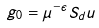<formula> <loc_0><loc_0><loc_500><loc_500>g _ { 0 } = \mu ^ { - \epsilon } S _ { d } u</formula> 